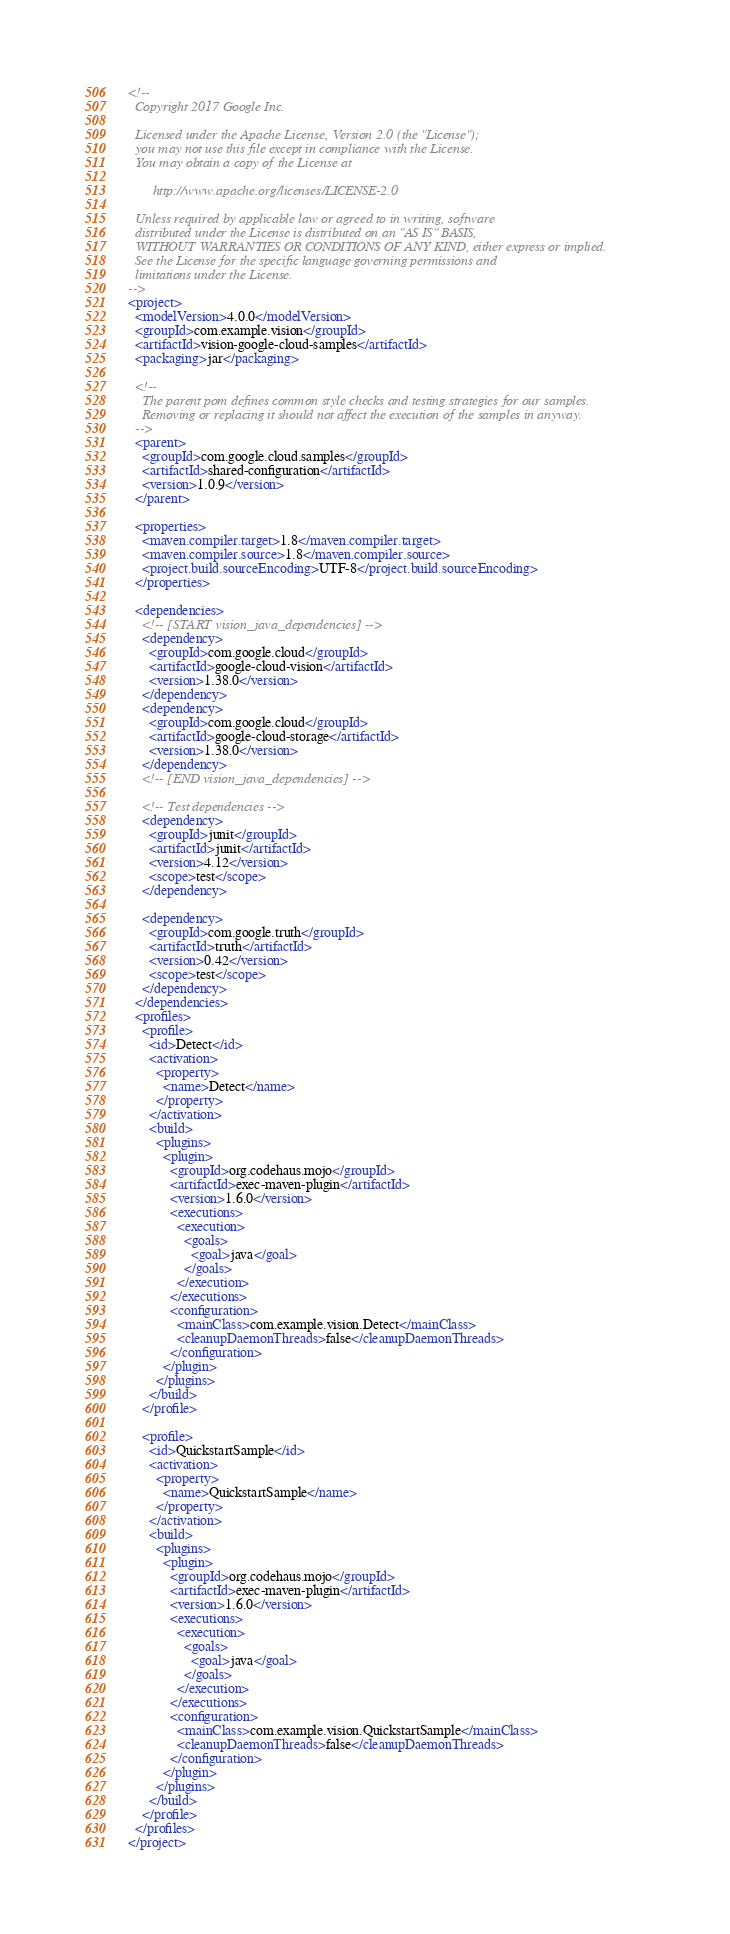<code> <loc_0><loc_0><loc_500><loc_500><_XML_><!--
  Copyright 2017 Google Inc.

  Licensed under the Apache License, Version 2.0 (the "License");
  you may not use this file except in compliance with the License.
  You may obtain a copy of the License at

       http://www.apache.org/licenses/LICENSE-2.0

  Unless required by applicable law or agreed to in writing, software
  distributed under the License is distributed on an "AS IS" BASIS,
  WITHOUT WARRANTIES OR CONDITIONS OF ANY KIND, either express or implied.
  See the License for the specific language governing permissions and
  limitations under the License.
-->
<project>
  <modelVersion>4.0.0</modelVersion>
  <groupId>com.example.vision</groupId>
  <artifactId>vision-google-cloud-samples</artifactId>
  <packaging>jar</packaging>

  <!--
    The parent pom defines common style checks and testing strategies for our samples.
    Removing or replacing it should not affect the execution of the samples in anyway.
  -->
  <parent>
    <groupId>com.google.cloud.samples</groupId>
    <artifactId>shared-configuration</artifactId>
    <version>1.0.9</version>
  </parent>

  <properties>
    <maven.compiler.target>1.8</maven.compiler.target>
    <maven.compiler.source>1.8</maven.compiler.source>
    <project.build.sourceEncoding>UTF-8</project.build.sourceEncoding>
  </properties>

  <dependencies>
    <!-- [START vision_java_dependencies] -->
    <dependency>
      <groupId>com.google.cloud</groupId>
      <artifactId>google-cloud-vision</artifactId>
      <version>1.38.0</version>
    </dependency>
    <dependency>
      <groupId>com.google.cloud</groupId>
      <artifactId>google-cloud-storage</artifactId>
      <version>1.38.0</version>
    </dependency>
    <!-- [END vision_java_dependencies] -->

    <!-- Test dependencies -->
    <dependency>
      <groupId>junit</groupId>
      <artifactId>junit</artifactId>
      <version>4.12</version>
      <scope>test</scope>
    </dependency>

    <dependency>
      <groupId>com.google.truth</groupId>
      <artifactId>truth</artifactId>
      <version>0.42</version>
      <scope>test</scope>
    </dependency>
  </dependencies>
  <profiles>
    <profile>
      <id>Detect</id>
      <activation>
        <property>
          <name>Detect</name>
        </property>
      </activation>
      <build>
        <plugins>
          <plugin>
            <groupId>org.codehaus.mojo</groupId>
            <artifactId>exec-maven-plugin</artifactId>
            <version>1.6.0</version>
            <executions>
              <execution>
                <goals>
                  <goal>java</goal>
                </goals>
              </execution>
            </executions>
            <configuration>
              <mainClass>com.example.vision.Detect</mainClass>
              <cleanupDaemonThreads>false</cleanupDaemonThreads>
            </configuration>
          </plugin>
        </plugins>
      </build>
    </profile>

    <profile>
      <id>QuickstartSample</id>
      <activation>
        <property>
          <name>QuickstartSample</name>
        </property>
      </activation>
      <build>
        <plugins>
          <plugin>
            <groupId>org.codehaus.mojo</groupId>
            <artifactId>exec-maven-plugin</artifactId>
            <version>1.6.0</version>
            <executions>
              <execution>
                <goals>
                  <goal>java</goal>
                </goals>
              </execution>
            </executions>
            <configuration>
              <mainClass>com.example.vision.QuickstartSample</mainClass>
              <cleanupDaemonThreads>false</cleanupDaemonThreads>
            </configuration>
          </plugin>
        </plugins>
      </build>
    </profile>
  </profiles>
</project>
</code> 